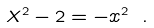Convert formula to latex. <formula><loc_0><loc_0><loc_500><loc_500>X ^ { 2 } - 2 = - x ^ { 2 } \ .</formula> 